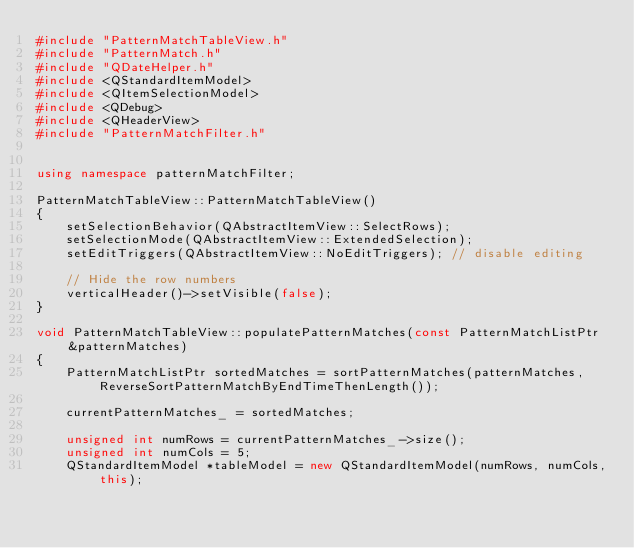Convert code to text. <code><loc_0><loc_0><loc_500><loc_500><_C++_>#include "PatternMatchTableView.h"
#include "PatternMatch.h"
#include "QDateHelper.h"
#include <QStandardItemModel>
#include <QItemSelectionModel>
#include <QDebug>
#include <QHeaderView>
#include "PatternMatchFilter.h"


using namespace patternMatchFilter;

PatternMatchTableView::PatternMatchTableView()
{
    setSelectionBehavior(QAbstractItemView::SelectRows);
    setSelectionMode(QAbstractItemView::ExtendedSelection);
    setEditTriggers(QAbstractItemView::NoEditTriggers); // disable editing

    // Hide the row numbers
    verticalHeader()->setVisible(false);
}

void PatternMatchTableView::populatePatternMatches(const PatternMatchListPtr &patternMatches)
{
    PatternMatchListPtr sortedMatches = sortPatternMatches(patternMatches,ReverseSortPatternMatchByEndTimeThenLength());

    currentPatternMatches_ = sortedMatches;

    unsigned int numRows = currentPatternMatches_->size();
    unsigned int numCols = 5;
    QStandardItemModel *tableModel = new QStandardItemModel(numRows, numCols,this);
</code> 